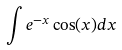<formula> <loc_0><loc_0><loc_500><loc_500>\int e ^ { - x } \cos ( x ) d x</formula> 